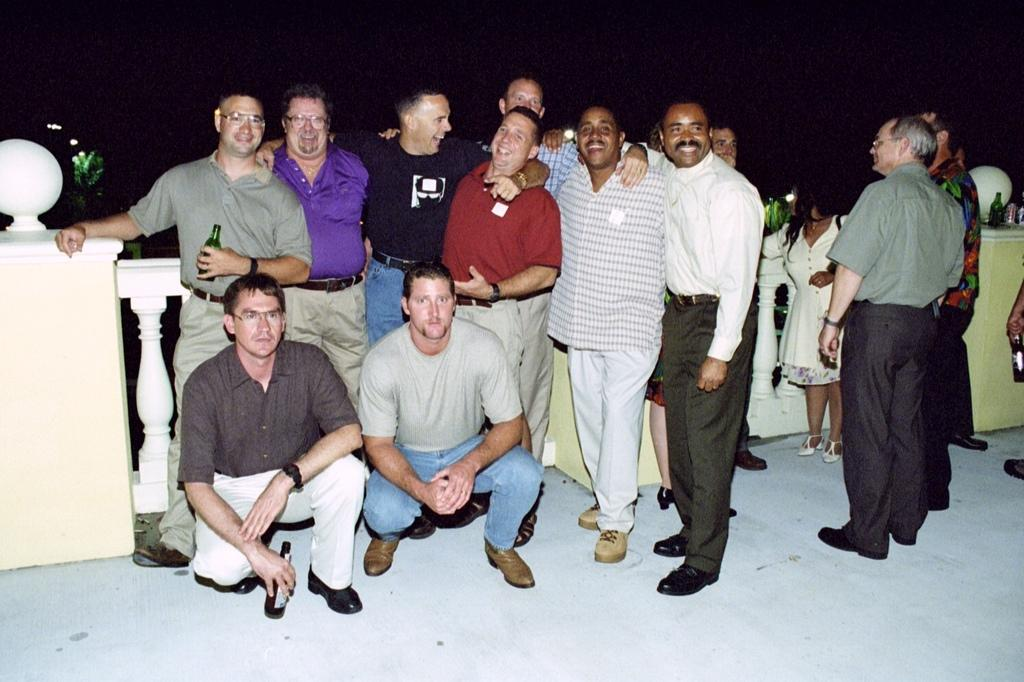What is happening in the middle of the picture? There are men standing in the middle of the picture. What are some of the men holding in their hands? Some of the men are holding bottles in their hands. What can be observed about the background of the image? The background of the image is dark. What type of juice is being drained onto the floor in the image? There is no juice or floor present in the image; it only features men standing with bottles in their hands against a dark background. 